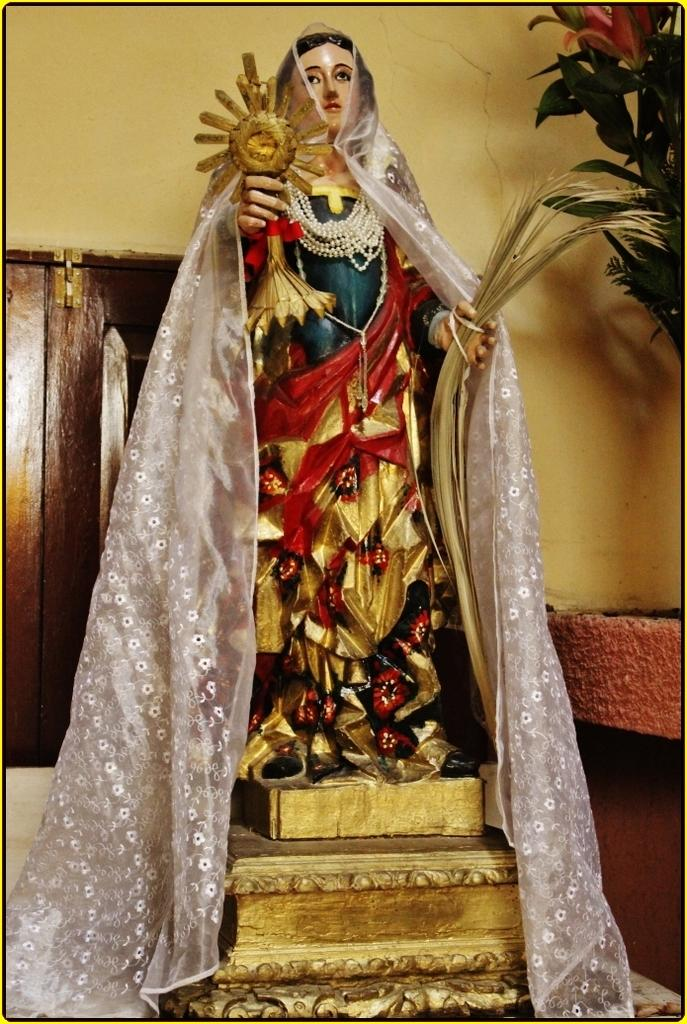What is the main subject in the image? There is a statue in the image. What is covering the statue? A cloth is placed on the statue. What other object can be seen in the image? There is a plant in the image. What architectural feature is visible in the image? There is a window visible in the image. What type of wax is being used to create the goose sculpture in the image? There is no goose sculpture present in the image, and therefore no wax can be associated with it. 